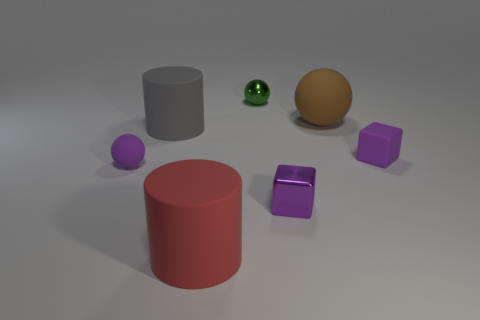Are there any small matte things of the same color as the tiny metal cube?
Your answer should be compact. Yes. What color is the other cylinder that is the same size as the red matte cylinder?
Make the answer very short. Gray. There is a tiny block that is on the right side of the brown rubber object; does it have the same color as the big rubber sphere?
Ensure brevity in your answer.  No. Are there any gray cylinders that have the same material as the big red object?
Make the answer very short. Yes. What is the shape of the small matte thing that is the same color as the rubber cube?
Offer a very short reply. Sphere. Is the number of large gray matte objects behind the gray rubber cylinder less than the number of big purple rubber things?
Ensure brevity in your answer.  No. There is a purple thing behind the purple sphere; does it have the same size as the small purple sphere?
Make the answer very short. Yes. What number of other things are the same shape as the red thing?
Give a very brief answer. 1. There is a gray thing that is made of the same material as the big brown ball; what size is it?
Give a very brief answer. Large. Are there the same number of big gray rubber things that are behind the gray thing and purple metallic cylinders?
Provide a short and direct response. Yes. 